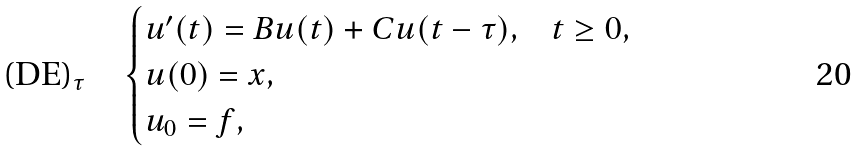<formula> <loc_0><loc_0><loc_500><loc_500>\text {(DE)} _ { \tau } \quad \begin{cases} u ^ { \prime } ( t ) = B u ( t ) + C u ( t - \tau ) , & t \geq 0 , \\ u ( 0 ) = x , & \\ u _ { 0 } = f , & \end{cases}</formula> 